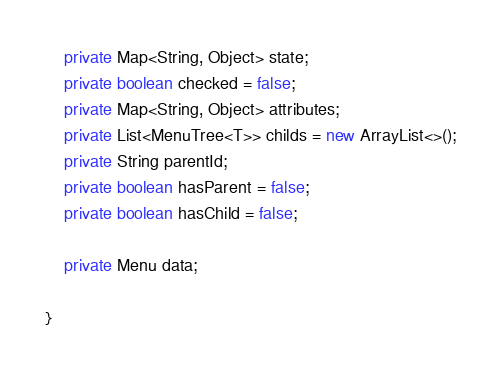Convert code to text. <code><loc_0><loc_0><loc_500><loc_500><_Java_>    private Map<String, Object> state;
    private boolean checked = false;
    private Map<String, Object> attributes;
    private List<MenuTree<T>> childs = new ArrayList<>();
    private String parentId;
    private boolean hasParent = false;
    private boolean hasChild = false;

    private Menu data;

}</code> 